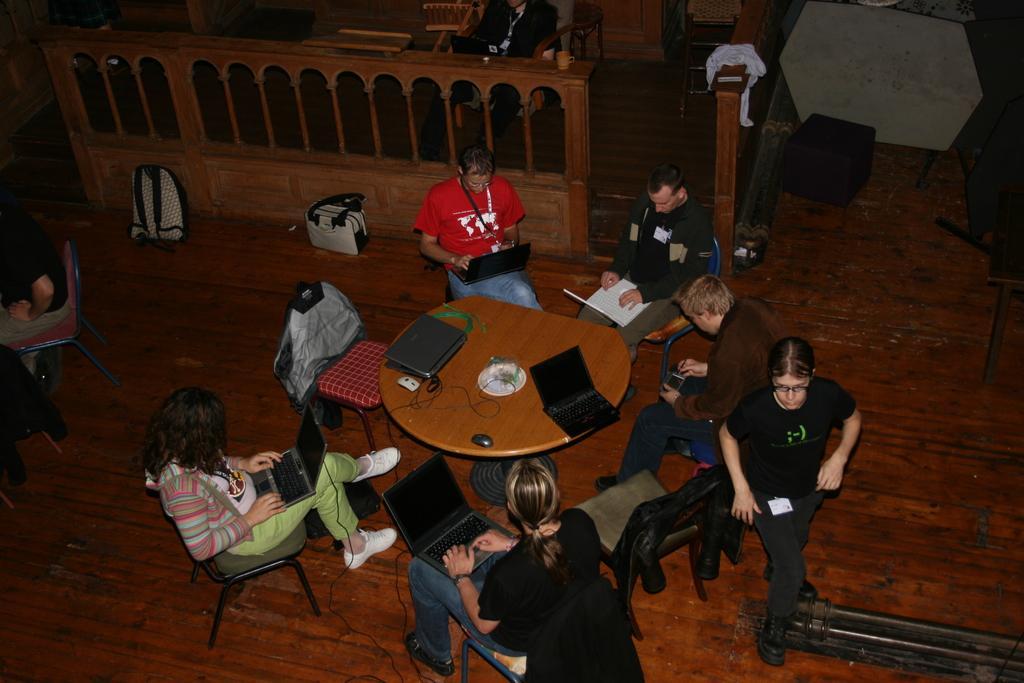Please provide a concise description of this image. In the image few people are sitting and holding some laptops and there are some bags and tables, on the tables there are some laptops and mouses and wires. Behind them there is fencing. Behind the fencing there are some chairs and tables. 